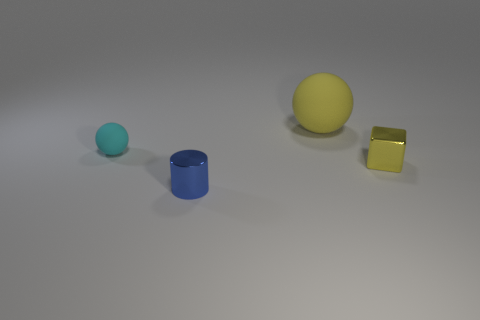Is there anything else that is the same size as the yellow sphere?
Your answer should be compact. No. Does the small metal thing right of the big yellow rubber object have the same color as the sphere to the left of the metal cylinder?
Give a very brief answer. No. What is the material of the blue thing that is the same size as the yellow cube?
Keep it short and to the point. Metal. Is there a cylinder that has the same size as the cube?
Your answer should be very brief. Yes. Are there fewer yellow shiny cubes in front of the cyan matte object than tiny gray rubber objects?
Your answer should be very brief. No. Is the number of small cyan balls that are to the left of the yellow shiny object less than the number of yellow shiny blocks behind the big yellow object?
Your response must be concise. No. How many cylinders are small things or blue metal objects?
Provide a succinct answer. 1. Is the material of the sphere to the right of the cyan matte ball the same as the thing left of the small blue metallic cylinder?
Give a very brief answer. Yes. What shape is the blue metal object that is the same size as the cyan matte object?
Provide a short and direct response. Cylinder. What number of other things are there of the same color as the metallic cylinder?
Give a very brief answer. 0. 